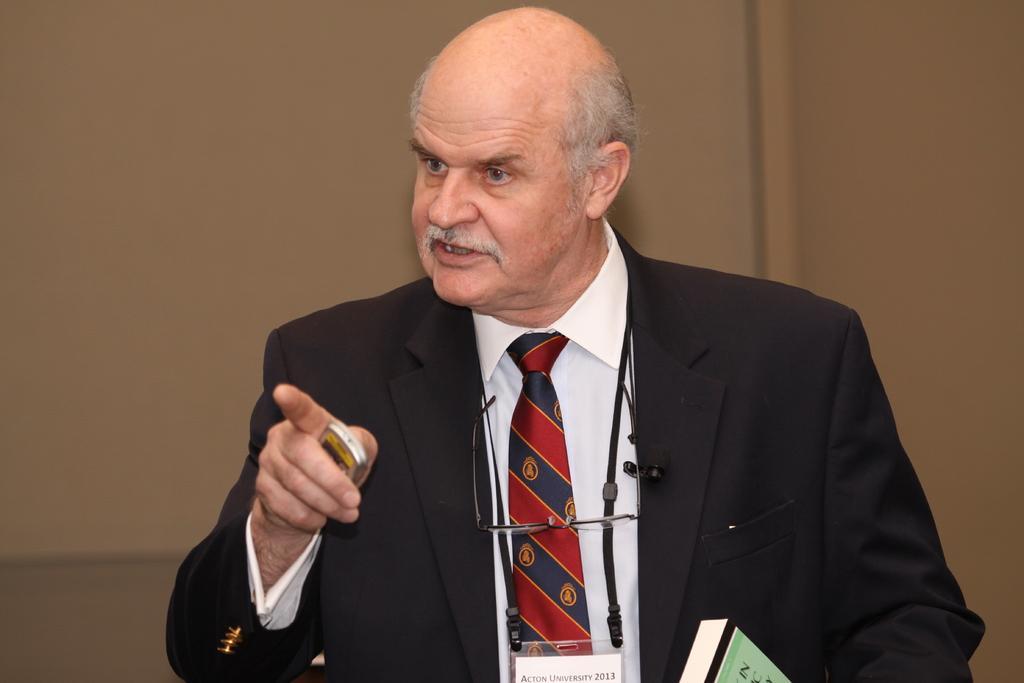Could you give a brief overview of what you see in this image? In this picture we can see a man wore a blazer, tie, holding a device with his hand and in front of him we can see a book, spectacles and in the background we can see the wall. 